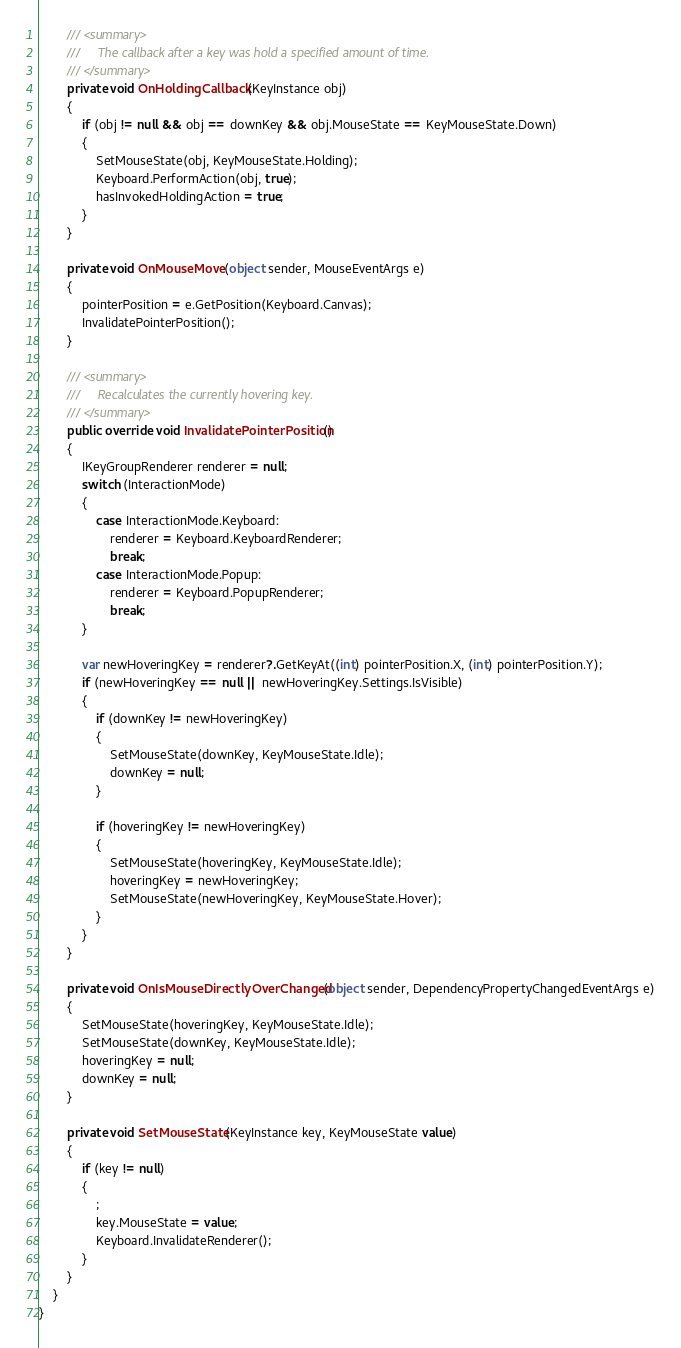<code> <loc_0><loc_0><loc_500><loc_500><_C#_>
        /// <summary>
        ///     The callback after a key was hold a specified amount of time.
        /// </summary>
        private void OnHoldingCallback(KeyInstance obj)
        {
            if (obj != null && obj == downKey && obj.MouseState == KeyMouseState.Down)
            {
                SetMouseState(obj, KeyMouseState.Holding);
                Keyboard.PerformAction(obj, true);
                hasInvokedHoldingAction = true;
            }
        }

        private void OnMouseMove(object sender, MouseEventArgs e)
        {
            pointerPosition = e.GetPosition(Keyboard.Canvas);
            InvalidatePointerPosition();
        }

        /// <summary>
        ///     Recalculates the currently hovering key.
        /// </summary>
        public override void InvalidatePointerPosition()
        {
            IKeyGroupRenderer renderer = null;
            switch (InteractionMode)
            {
                case InteractionMode.Keyboard:
                    renderer = Keyboard.KeyboardRenderer;
                    break;
                case InteractionMode.Popup:
                    renderer = Keyboard.PopupRenderer;
                    break;
            }

            var newHoveringKey = renderer?.GetKeyAt((int) pointerPosition.X, (int) pointerPosition.Y);
            if (newHoveringKey == null || newHoveringKey.Settings.IsVisible)
            {
                if (downKey != newHoveringKey)
                {
                    SetMouseState(downKey, KeyMouseState.Idle);
                    downKey = null;
                }

                if (hoveringKey != newHoveringKey)
                {
                    SetMouseState(hoveringKey, KeyMouseState.Idle);
                    hoveringKey = newHoveringKey;
                    SetMouseState(newHoveringKey, KeyMouseState.Hover);
                }
            }
        }

        private void OnIsMouseDirectlyOverChanged(object sender, DependencyPropertyChangedEventArgs e)
        {
            SetMouseState(hoveringKey, KeyMouseState.Idle);
            SetMouseState(downKey, KeyMouseState.Idle);
            hoveringKey = null;
            downKey = null;
        }

        private void SetMouseState(KeyInstance key, KeyMouseState value)
        {
            if (key != null)
            {
                ;
                key.MouseState = value;
                Keyboard.InvalidateRenderer();
            }
        }
    }
}</code> 